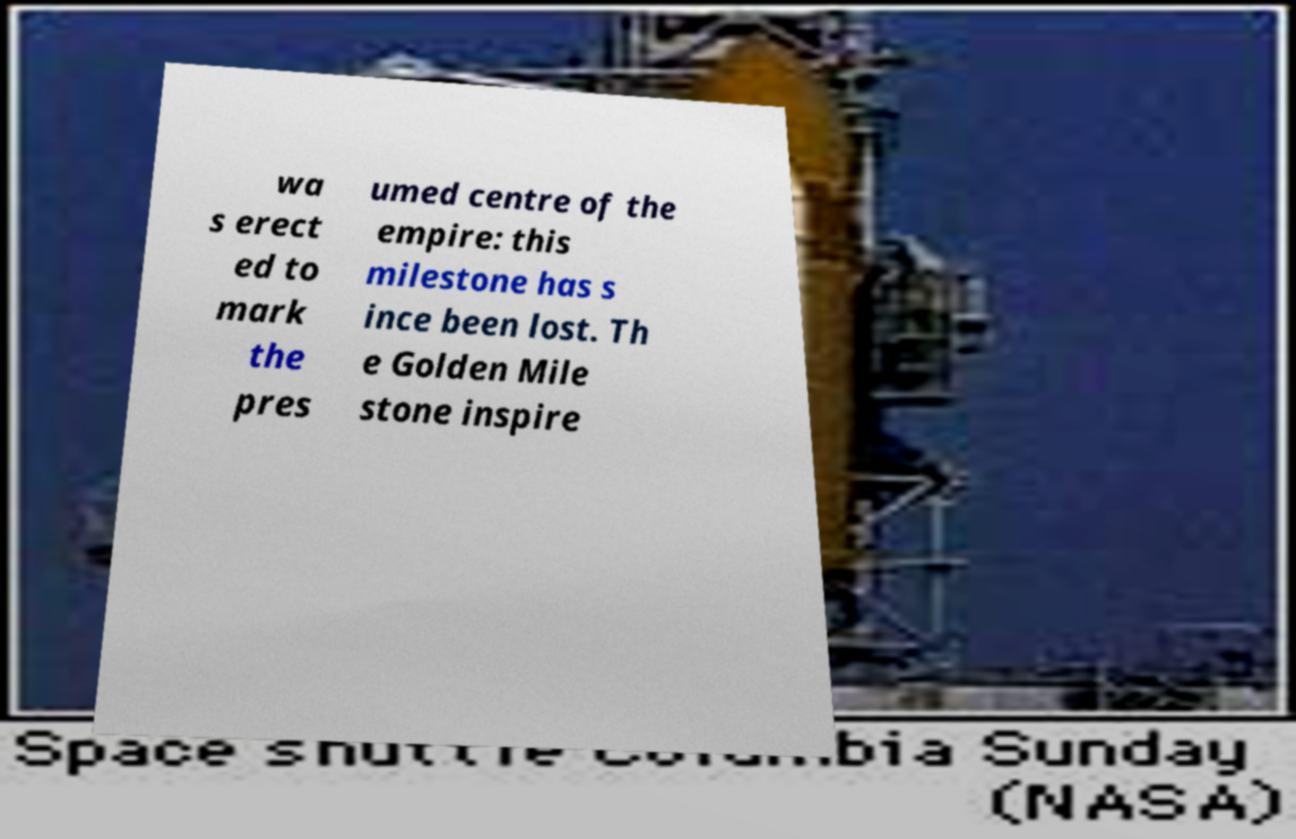There's text embedded in this image that I need extracted. Can you transcribe it verbatim? wa s erect ed to mark the pres umed centre of the empire: this milestone has s ince been lost. Th e Golden Mile stone inspire 